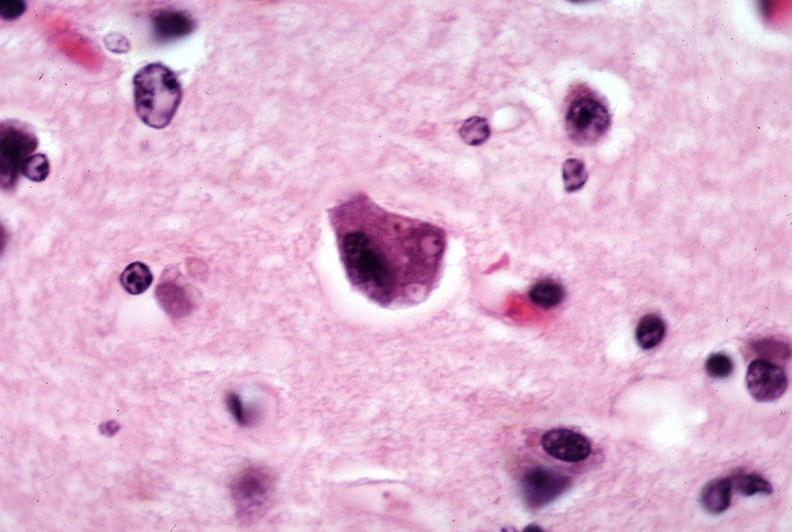s nervous present?
Answer the question using a single word or phrase. Yes 